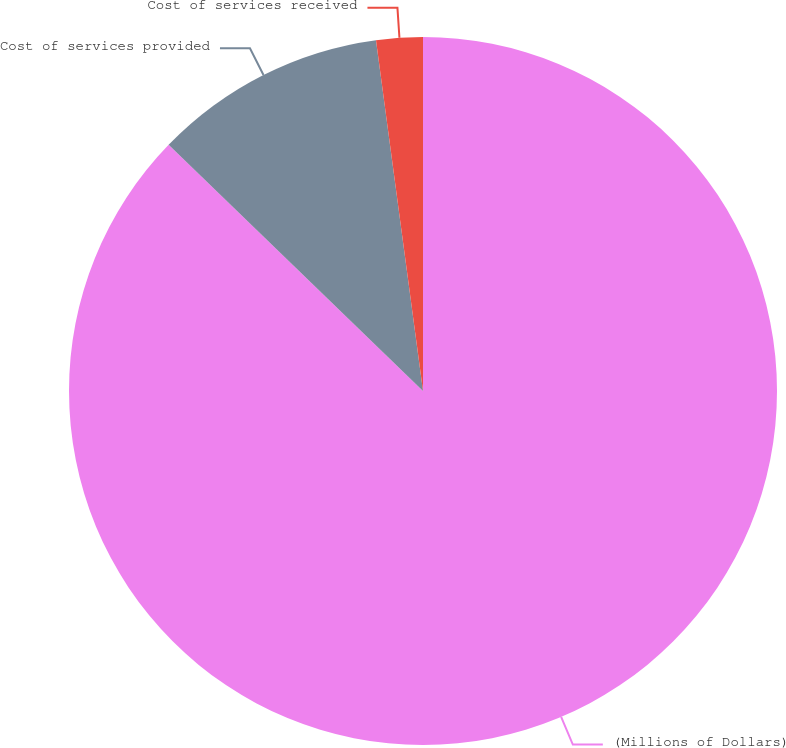<chart> <loc_0><loc_0><loc_500><loc_500><pie_chart><fcel>(Millions of Dollars)<fcel>Cost of services provided<fcel>Cost of services received<nl><fcel>87.24%<fcel>10.64%<fcel>2.12%<nl></chart> 